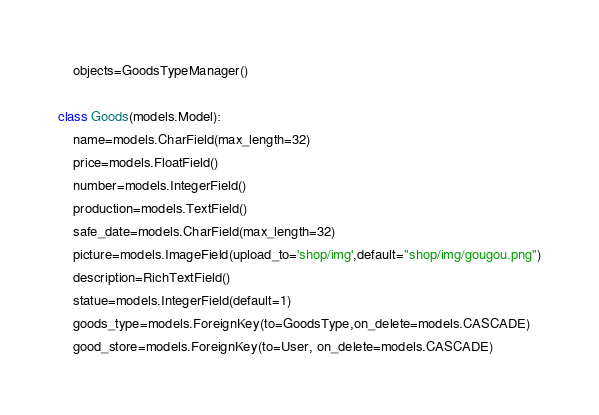<code> <loc_0><loc_0><loc_500><loc_500><_Python_>    objects=GoodsTypeManager()

class Goods(models.Model):
    name=models.CharField(max_length=32)
    price=models.FloatField()
    number=models.IntegerField()
    production=models.TextField()
    safe_date=models.CharField(max_length=32)
    picture=models.ImageField(upload_to='shop/img',default="shop/img/gougou.png")
    description=RichTextField()
    statue=models.IntegerField(default=1)
    goods_type=models.ForeignKey(to=GoodsType,on_delete=models.CASCADE)
    good_store=models.ForeignKey(to=User, on_delete=models.CASCADE)
</code> 